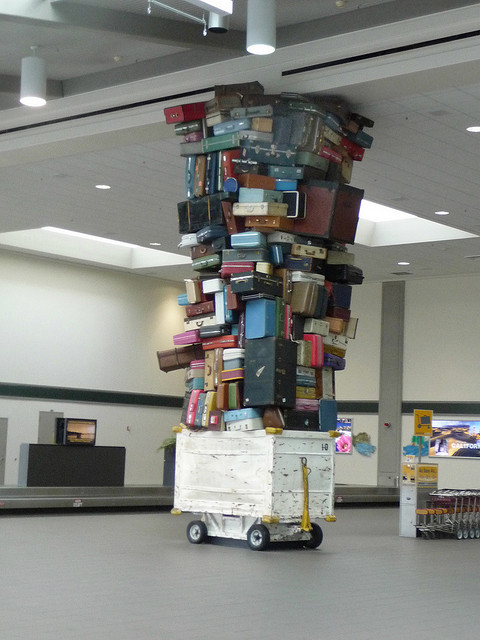How many bikes are? Upon reviewing the image, there doesn't appear to be any bicycles present. The focus of the image is a large tower of suitcases and other luggage items stacked on top of a platform with wheels. 